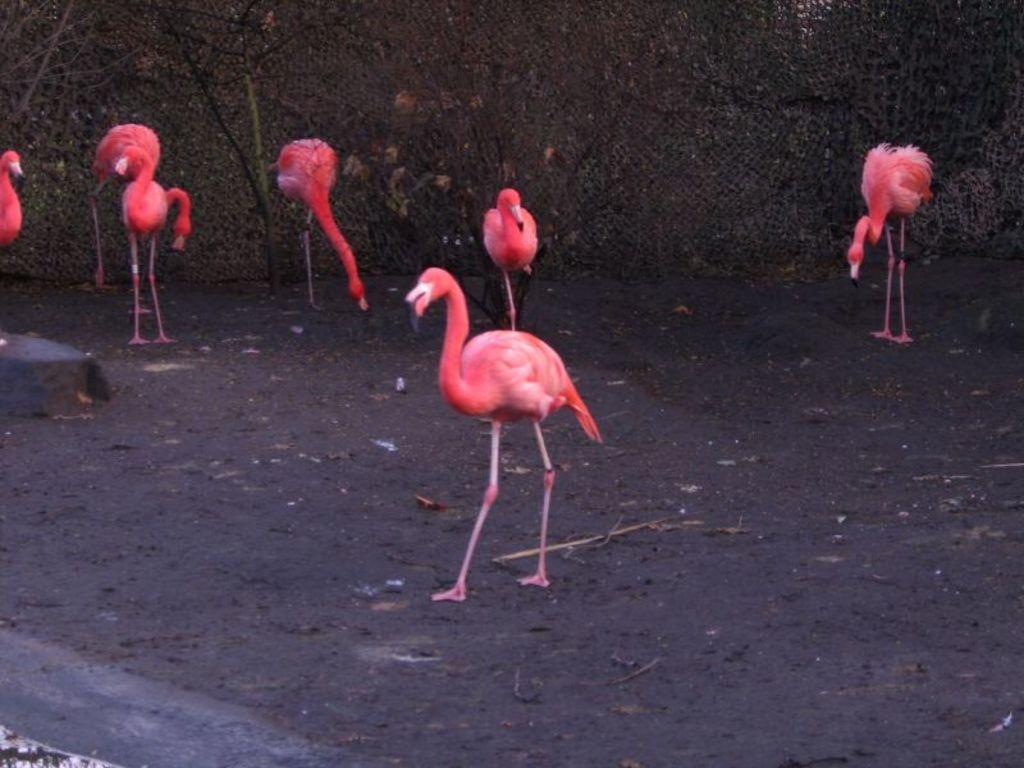Can you describe this image briefly? This picture is clicked outside. In the center we can see the group of flamingos standing on the ground. In the background we can see the trees and some other objects. 